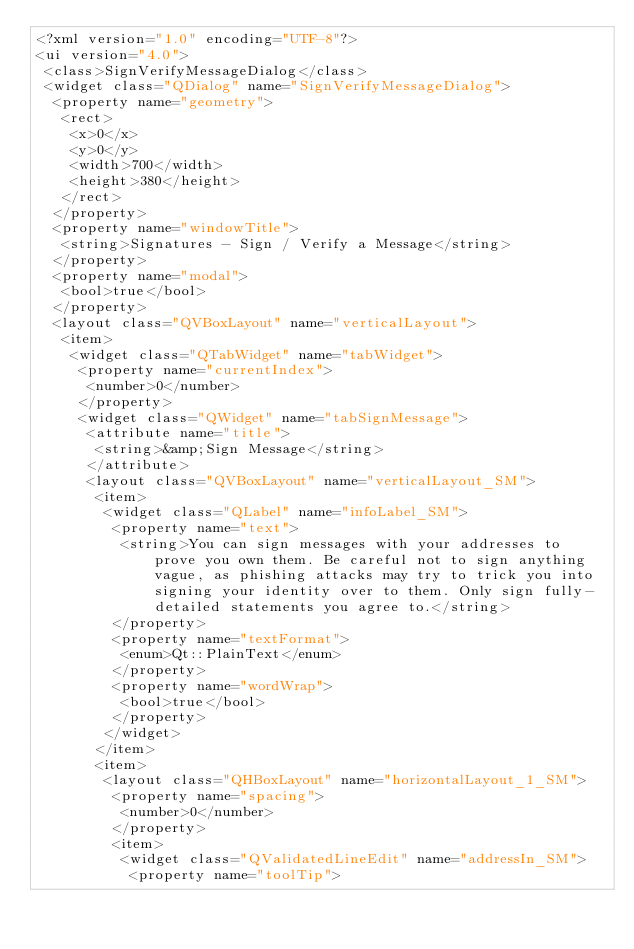Convert code to text. <code><loc_0><loc_0><loc_500><loc_500><_XML_><?xml version="1.0" encoding="UTF-8"?>
<ui version="4.0">
 <class>SignVerifyMessageDialog</class>
 <widget class="QDialog" name="SignVerifyMessageDialog">
  <property name="geometry">
   <rect>
    <x>0</x>
    <y>0</y>
    <width>700</width>
    <height>380</height>
   </rect>
  </property>
  <property name="windowTitle">
   <string>Signatures - Sign / Verify a Message</string>
  </property>
  <property name="modal">
   <bool>true</bool>
  </property>
  <layout class="QVBoxLayout" name="verticalLayout">
   <item>
    <widget class="QTabWidget" name="tabWidget">
     <property name="currentIndex">
      <number>0</number>
     </property>
     <widget class="QWidget" name="tabSignMessage">
      <attribute name="title">
       <string>&amp;Sign Message</string>
      </attribute>
      <layout class="QVBoxLayout" name="verticalLayout_SM">
       <item>
        <widget class="QLabel" name="infoLabel_SM">
         <property name="text">
          <string>You can sign messages with your addresses to prove you own them. Be careful not to sign anything vague, as phishing attacks may try to trick you into signing your identity over to them. Only sign fully-detailed statements you agree to.</string>
         </property>
         <property name="textFormat">
          <enum>Qt::PlainText</enum>
         </property>
         <property name="wordWrap">
          <bool>true</bool>
         </property>
        </widget>
       </item>
       <item>
        <layout class="QHBoxLayout" name="horizontalLayout_1_SM">
         <property name="spacing">
          <number>0</number>
         </property>
         <item>
          <widget class="QValidatedLineEdit" name="addressIn_SM">
           <property name="toolTip"></code> 